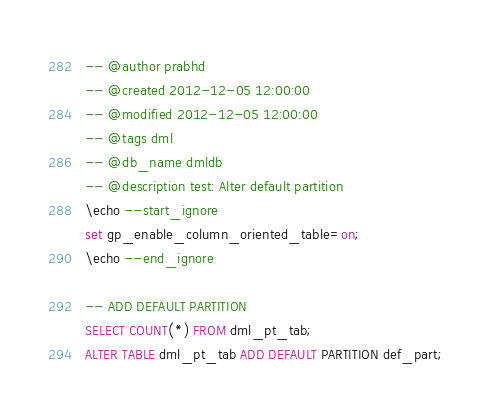Convert code to text. <code><loc_0><loc_0><loc_500><loc_500><_SQL_>-- @author prabhd
-- @created 2012-12-05 12:00:00
-- @modified 2012-12-05 12:00:00
-- @tags dml
-- @db_name dmldb
-- @description test: Alter default partition
\echo --start_ignore
set gp_enable_column_oriented_table=on;
\echo --end_ignore

-- ADD DEFAULT PARTITION
SELECT COUNT(*) FROM dml_pt_tab;
ALTER TABLE dml_pt_tab ADD DEFAULT PARTITION def_part;</code> 